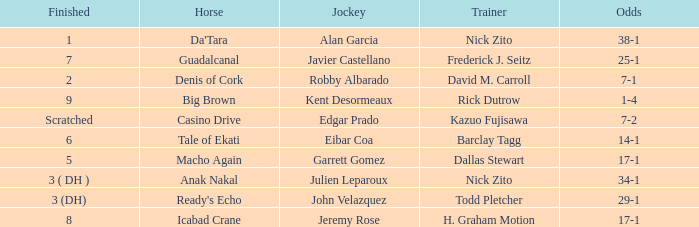Which Horse finished in 8? Icabad Crane. 